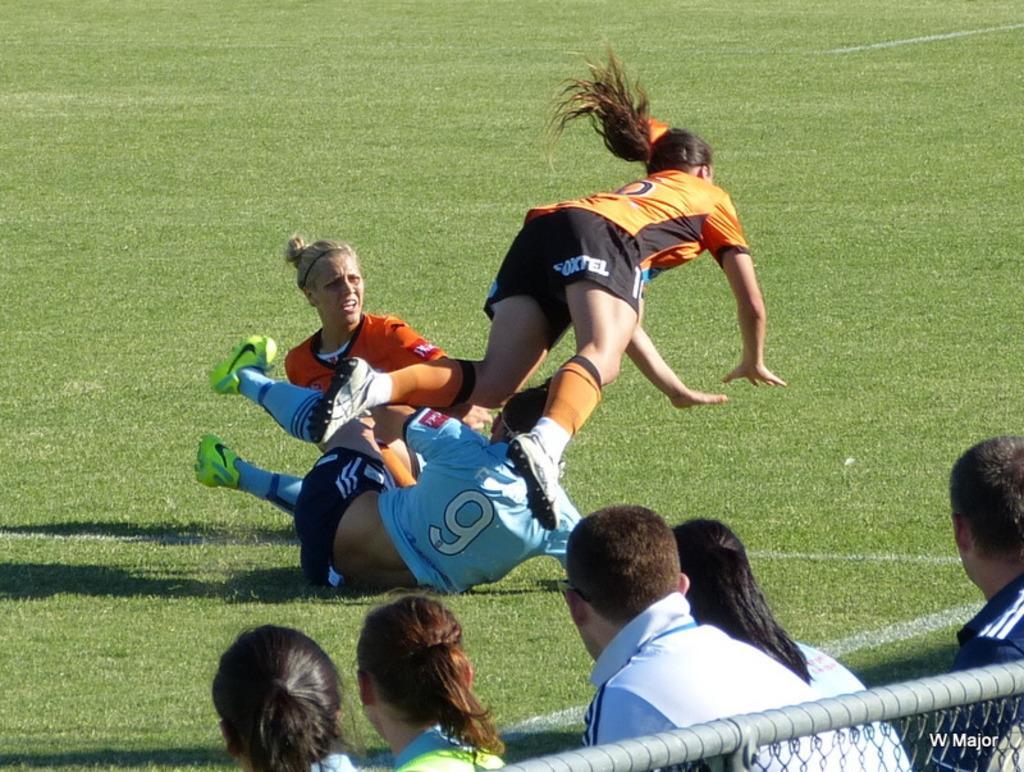Can you describe this image briefly? In this image we can see few people, some of them are playing in the ground and there is a metal rod with fence. 